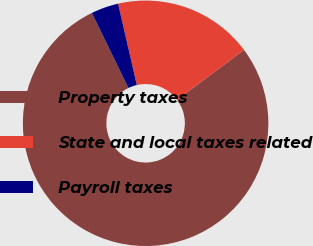<chart> <loc_0><loc_0><loc_500><loc_500><pie_chart><fcel>Property taxes<fcel>State and local taxes related<fcel>Payroll taxes<nl><fcel>77.98%<fcel>18.41%<fcel>3.61%<nl></chart> 